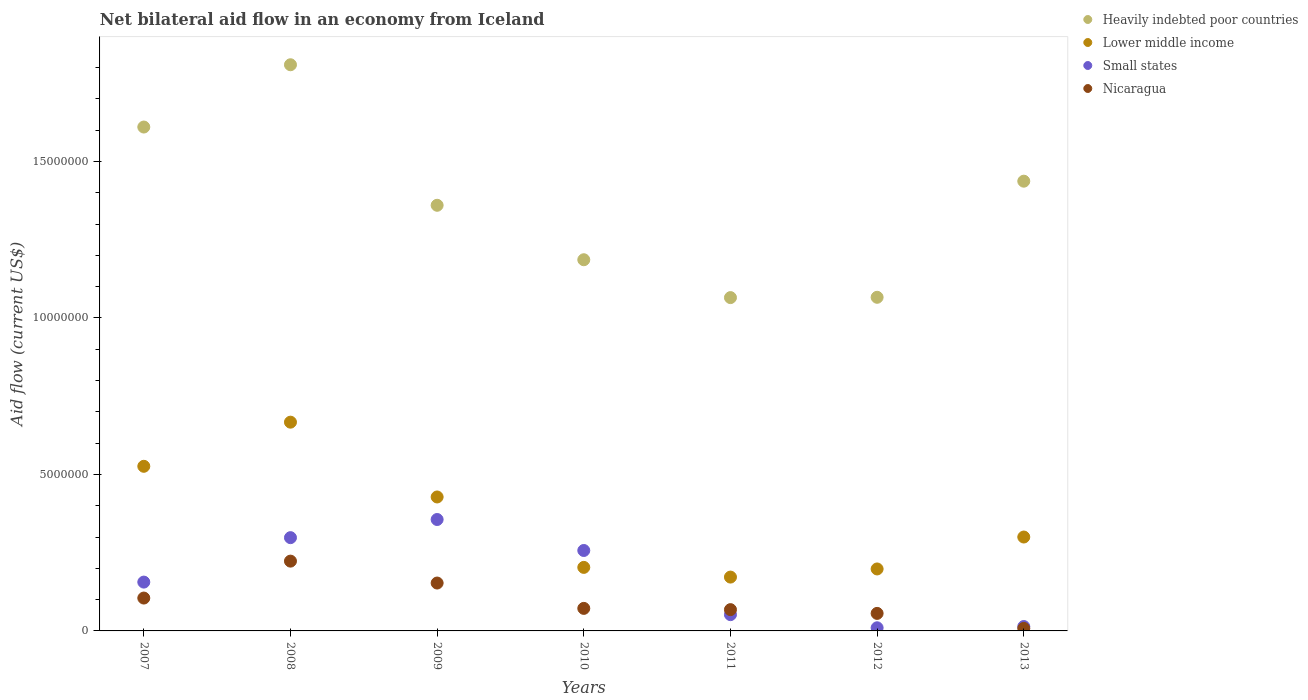What is the net bilateral aid flow in Nicaragua in 2010?
Provide a succinct answer. 7.20e+05. Across all years, what is the maximum net bilateral aid flow in Lower middle income?
Keep it short and to the point. 6.67e+06. Across all years, what is the minimum net bilateral aid flow in Lower middle income?
Your answer should be very brief. 1.72e+06. In which year was the net bilateral aid flow in Small states minimum?
Provide a short and direct response. 2012. What is the total net bilateral aid flow in Lower middle income in the graph?
Your answer should be compact. 2.49e+07. What is the difference between the net bilateral aid flow in Small states in 2007 and that in 2013?
Keep it short and to the point. 1.42e+06. What is the difference between the net bilateral aid flow in Lower middle income in 2009 and the net bilateral aid flow in Heavily indebted poor countries in 2008?
Your answer should be compact. -1.38e+07. What is the average net bilateral aid flow in Heavily indebted poor countries per year?
Provide a succinct answer. 1.36e+07. In the year 2011, what is the difference between the net bilateral aid flow in Lower middle income and net bilateral aid flow in Heavily indebted poor countries?
Your response must be concise. -8.93e+06. What is the ratio of the net bilateral aid flow in Heavily indebted poor countries in 2007 to that in 2009?
Your answer should be compact. 1.18. What is the difference between the highest and the second highest net bilateral aid flow in Heavily indebted poor countries?
Your answer should be compact. 1.99e+06. What is the difference between the highest and the lowest net bilateral aid flow in Small states?
Provide a succinct answer. 3.46e+06. In how many years, is the net bilateral aid flow in Small states greater than the average net bilateral aid flow in Small states taken over all years?
Make the answer very short. 3. How many dotlines are there?
Keep it short and to the point. 4. What is the difference between two consecutive major ticks on the Y-axis?
Make the answer very short. 5.00e+06. Are the values on the major ticks of Y-axis written in scientific E-notation?
Provide a short and direct response. No. Does the graph contain any zero values?
Provide a short and direct response. No. Does the graph contain grids?
Make the answer very short. No. Where does the legend appear in the graph?
Keep it short and to the point. Top right. How many legend labels are there?
Offer a terse response. 4. What is the title of the graph?
Make the answer very short. Net bilateral aid flow in an economy from Iceland. Does "Croatia" appear as one of the legend labels in the graph?
Provide a succinct answer. No. What is the label or title of the Y-axis?
Give a very brief answer. Aid flow (current US$). What is the Aid flow (current US$) in Heavily indebted poor countries in 2007?
Offer a very short reply. 1.61e+07. What is the Aid flow (current US$) in Lower middle income in 2007?
Your response must be concise. 5.26e+06. What is the Aid flow (current US$) of Small states in 2007?
Offer a terse response. 1.56e+06. What is the Aid flow (current US$) of Nicaragua in 2007?
Your response must be concise. 1.05e+06. What is the Aid flow (current US$) of Heavily indebted poor countries in 2008?
Provide a short and direct response. 1.81e+07. What is the Aid flow (current US$) of Lower middle income in 2008?
Your answer should be very brief. 6.67e+06. What is the Aid flow (current US$) of Small states in 2008?
Your answer should be very brief. 2.98e+06. What is the Aid flow (current US$) of Nicaragua in 2008?
Offer a very short reply. 2.23e+06. What is the Aid flow (current US$) in Heavily indebted poor countries in 2009?
Your response must be concise. 1.36e+07. What is the Aid flow (current US$) of Lower middle income in 2009?
Provide a succinct answer. 4.28e+06. What is the Aid flow (current US$) in Small states in 2009?
Your answer should be very brief. 3.56e+06. What is the Aid flow (current US$) of Nicaragua in 2009?
Make the answer very short. 1.53e+06. What is the Aid flow (current US$) of Heavily indebted poor countries in 2010?
Make the answer very short. 1.19e+07. What is the Aid flow (current US$) in Lower middle income in 2010?
Ensure brevity in your answer.  2.03e+06. What is the Aid flow (current US$) of Small states in 2010?
Offer a very short reply. 2.57e+06. What is the Aid flow (current US$) of Nicaragua in 2010?
Provide a short and direct response. 7.20e+05. What is the Aid flow (current US$) in Heavily indebted poor countries in 2011?
Offer a terse response. 1.06e+07. What is the Aid flow (current US$) of Lower middle income in 2011?
Keep it short and to the point. 1.72e+06. What is the Aid flow (current US$) in Small states in 2011?
Keep it short and to the point. 5.20e+05. What is the Aid flow (current US$) of Nicaragua in 2011?
Offer a very short reply. 6.80e+05. What is the Aid flow (current US$) in Heavily indebted poor countries in 2012?
Offer a very short reply. 1.07e+07. What is the Aid flow (current US$) of Lower middle income in 2012?
Offer a terse response. 1.98e+06. What is the Aid flow (current US$) of Small states in 2012?
Ensure brevity in your answer.  1.00e+05. What is the Aid flow (current US$) of Nicaragua in 2012?
Your response must be concise. 5.60e+05. What is the Aid flow (current US$) in Heavily indebted poor countries in 2013?
Give a very brief answer. 1.44e+07. What is the Aid flow (current US$) in Lower middle income in 2013?
Offer a terse response. 3.00e+06. Across all years, what is the maximum Aid flow (current US$) in Heavily indebted poor countries?
Offer a terse response. 1.81e+07. Across all years, what is the maximum Aid flow (current US$) in Lower middle income?
Offer a very short reply. 6.67e+06. Across all years, what is the maximum Aid flow (current US$) in Small states?
Your response must be concise. 3.56e+06. Across all years, what is the maximum Aid flow (current US$) in Nicaragua?
Your answer should be compact. 2.23e+06. Across all years, what is the minimum Aid flow (current US$) in Heavily indebted poor countries?
Offer a terse response. 1.06e+07. Across all years, what is the minimum Aid flow (current US$) of Lower middle income?
Provide a succinct answer. 1.72e+06. What is the total Aid flow (current US$) in Heavily indebted poor countries in the graph?
Make the answer very short. 9.53e+07. What is the total Aid flow (current US$) in Lower middle income in the graph?
Your answer should be compact. 2.49e+07. What is the total Aid flow (current US$) of Small states in the graph?
Ensure brevity in your answer.  1.14e+07. What is the total Aid flow (current US$) of Nicaragua in the graph?
Offer a terse response. 6.85e+06. What is the difference between the Aid flow (current US$) of Heavily indebted poor countries in 2007 and that in 2008?
Your answer should be compact. -1.99e+06. What is the difference between the Aid flow (current US$) in Lower middle income in 2007 and that in 2008?
Keep it short and to the point. -1.41e+06. What is the difference between the Aid flow (current US$) in Small states in 2007 and that in 2008?
Make the answer very short. -1.42e+06. What is the difference between the Aid flow (current US$) of Nicaragua in 2007 and that in 2008?
Provide a short and direct response. -1.18e+06. What is the difference between the Aid flow (current US$) in Heavily indebted poor countries in 2007 and that in 2009?
Your response must be concise. 2.50e+06. What is the difference between the Aid flow (current US$) in Lower middle income in 2007 and that in 2009?
Your answer should be compact. 9.80e+05. What is the difference between the Aid flow (current US$) in Small states in 2007 and that in 2009?
Provide a short and direct response. -2.00e+06. What is the difference between the Aid flow (current US$) in Nicaragua in 2007 and that in 2009?
Ensure brevity in your answer.  -4.80e+05. What is the difference between the Aid flow (current US$) in Heavily indebted poor countries in 2007 and that in 2010?
Your answer should be very brief. 4.24e+06. What is the difference between the Aid flow (current US$) in Lower middle income in 2007 and that in 2010?
Your answer should be compact. 3.23e+06. What is the difference between the Aid flow (current US$) in Small states in 2007 and that in 2010?
Make the answer very short. -1.01e+06. What is the difference between the Aid flow (current US$) of Nicaragua in 2007 and that in 2010?
Provide a short and direct response. 3.30e+05. What is the difference between the Aid flow (current US$) of Heavily indebted poor countries in 2007 and that in 2011?
Offer a very short reply. 5.45e+06. What is the difference between the Aid flow (current US$) in Lower middle income in 2007 and that in 2011?
Offer a very short reply. 3.54e+06. What is the difference between the Aid flow (current US$) of Small states in 2007 and that in 2011?
Your response must be concise. 1.04e+06. What is the difference between the Aid flow (current US$) of Heavily indebted poor countries in 2007 and that in 2012?
Ensure brevity in your answer.  5.44e+06. What is the difference between the Aid flow (current US$) of Lower middle income in 2007 and that in 2012?
Give a very brief answer. 3.28e+06. What is the difference between the Aid flow (current US$) in Small states in 2007 and that in 2012?
Offer a terse response. 1.46e+06. What is the difference between the Aid flow (current US$) of Heavily indebted poor countries in 2007 and that in 2013?
Offer a terse response. 1.73e+06. What is the difference between the Aid flow (current US$) of Lower middle income in 2007 and that in 2013?
Provide a short and direct response. 2.26e+06. What is the difference between the Aid flow (current US$) in Small states in 2007 and that in 2013?
Your answer should be compact. 1.42e+06. What is the difference between the Aid flow (current US$) in Nicaragua in 2007 and that in 2013?
Provide a succinct answer. 9.70e+05. What is the difference between the Aid flow (current US$) in Heavily indebted poor countries in 2008 and that in 2009?
Make the answer very short. 4.49e+06. What is the difference between the Aid flow (current US$) of Lower middle income in 2008 and that in 2009?
Ensure brevity in your answer.  2.39e+06. What is the difference between the Aid flow (current US$) of Small states in 2008 and that in 2009?
Keep it short and to the point. -5.80e+05. What is the difference between the Aid flow (current US$) of Nicaragua in 2008 and that in 2009?
Keep it short and to the point. 7.00e+05. What is the difference between the Aid flow (current US$) in Heavily indebted poor countries in 2008 and that in 2010?
Keep it short and to the point. 6.23e+06. What is the difference between the Aid flow (current US$) in Lower middle income in 2008 and that in 2010?
Make the answer very short. 4.64e+06. What is the difference between the Aid flow (current US$) in Small states in 2008 and that in 2010?
Give a very brief answer. 4.10e+05. What is the difference between the Aid flow (current US$) in Nicaragua in 2008 and that in 2010?
Your answer should be very brief. 1.51e+06. What is the difference between the Aid flow (current US$) of Heavily indebted poor countries in 2008 and that in 2011?
Make the answer very short. 7.44e+06. What is the difference between the Aid flow (current US$) of Lower middle income in 2008 and that in 2011?
Your answer should be compact. 4.95e+06. What is the difference between the Aid flow (current US$) of Small states in 2008 and that in 2011?
Offer a terse response. 2.46e+06. What is the difference between the Aid flow (current US$) of Nicaragua in 2008 and that in 2011?
Offer a terse response. 1.55e+06. What is the difference between the Aid flow (current US$) in Heavily indebted poor countries in 2008 and that in 2012?
Your response must be concise. 7.43e+06. What is the difference between the Aid flow (current US$) of Lower middle income in 2008 and that in 2012?
Offer a very short reply. 4.69e+06. What is the difference between the Aid flow (current US$) of Small states in 2008 and that in 2012?
Your answer should be very brief. 2.88e+06. What is the difference between the Aid flow (current US$) in Nicaragua in 2008 and that in 2012?
Ensure brevity in your answer.  1.67e+06. What is the difference between the Aid flow (current US$) in Heavily indebted poor countries in 2008 and that in 2013?
Make the answer very short. 3.72e+06. What is the difference between the Aid flow (current US$) of Lower middle income in 2008 and that in 2013?
Your answer should be very brief. 3.67e+06. What is the difference between the Aid flow (current US$) in Small states in 2008 and that in 2013?
Your answer should be compact. 2.84e+06. What is the difference between the Aid flow (current US$) in Nicaragua in 2008 and that in 2013?
Keep it short and to the point. 2.15e+06. What is the difference between the Aid flow (current US$) in Heavily indebted poor countries in 2009 and that in 2010?
Keep it short and to the point. 1.74e+06. What is the difference between the Aid flow (current US$) of Lower middle income in 2009 and that in 2010?
Provide a short and direct response. 2.25e+06. What is the difference between the Aid flow (current US$) in Small states in 2009 and that in 2010?
Offer a very short reply. 9.90e+05. What is the difference between the Aid flow (current US$) of Nicaragua in 2009 and that in 2010?
Make the answer very short. 8.10e+05. What is the difference between the Aid flow (current US$) in Heavily indebted poor countries in 2009 and that in 2011?
Give a very brief answer. 2.95e+06. What is the difference between the Aid flow (current US$) of Lower middle income in 2009 and that in 2011?
Offer a terse response. 2.56e+06. What is the difference between the Aid flow (current US$) of Small states in 2009 and that in 2011?
Your response must be concise. 3.04e+06. What is the difference between the Aid flow (current US$) of Nicaragua in 2009 and that in 2011?
Provide a short and direct response. 8.50e+05. What is the difference between the Aid flow (current US$) of Heavily indebted poor countries in 2009 and that in 2012?
Make the answer very short. 2.94e+06. What is the difference between the Aid flow (current US$) in Lower middle income in 2009 and that in 2012?
Your answer should be very brief. 2.30e+06. What is the difference between the Aid flow (current US$) in Small states in 2009 and that in 2012?
Keep it short and to the point. 3.46e+06. What is the difference between the Aid flow (current US$) of Nicaragua in 2009 and that in 2012?
Your response must be concise. 9.70e+05. What is the difference between the Aid flow (current US$) of Heavily indebted poor countries in 2009 and that in 2013?
Give a very brief answer. -7.70e+05. What is the difference between the Aid flow (current US$) in Lower middle income in 2009 and that in 2013?
Offer a terse response. 1.28e+06. What is the difference between the Aid flow (current US$) in Small states in 2009 and that in 2013?
Offer a very short reply. 3.42e+06. What is the difference between the Aid flow (current US$) of Nicaragua in 2009 and that in 2013?
Provide a short and direct response. 1.45e+06. What is the difference between the Aid flow (current US$) in Heavily indebted poor countries in 2010 and that in 2011?
Your answer should be very brief. 1.21e+06. What is the difference between the Aid flow (current US$) of Lower middle income in 2010 and that in 2011?
Provide a short and direct response. 3.10e+05. What is the difference between the Aid flow (current US$) in Small states in 2010 and that in 2011?
Your answer should be compact. 2.05e+06. What is the difference between the Aid flow (current US$) in Nicaragua in 2010 and that in 2011?
Provide a succinct answer. 4.00e+04. What is the difference between the Aid flow (current US$) in Heavily indebted poor countries in 2010 and that in 2012?
Your response must be concise. 1.20e+06. What is the difference between the Aid flow (current US$) in Lower middle income in 2010 and that in 2012?
Keep it short and to the point. 5.00e+04. What is the difference between the Aid flow (current US$) in Small states in 2010 and that in 2012?
Keep it short and to the point. 2.47e+06. What is the difference between the Aid flow (current US$) in Nicaragua in 2010 and that in 2012?
Your response must be concise. 1.60e+05. What is the difference between the Aid flow (current US$) of Heavily indebted poor countries in 2010 and that in 2013?
Offer a very short reply. -2.51e+06. What is the difference between the Aid flow (current US$) of Lower middle income in 2010 and that in 2013?
Your response must be concise. -9.70e+05. What is the difference between the Aid flow (current US$) in Small states in 2010 and that in 2013?
Provide a short and direct response. 2.43e+06. What is the difference between the Aid flow (current US$) in Nicaragua in 2010 and that in 2013?
Offer a very short reply. 6.40e+05. What is the difference between the Aid flow (current US$) in Small states in 2011 and that in 2012?
Provide a short and direct response. 4.20e+05. What is the difference between the Aid flow (current US$) of Nicaragua in 2011 and that in 2012?
Your response must be concise. 1.20e+05. What is the difference between the Aid flow (current US$) in Heavily indebted poor countries in 2011 and that in 2013?
Offer a terse response. -3.72e+06. What is the difference between the Aid flow (current US$) in Lower middle income in 2011 and that in 2013?
Your response must be concise. -1.28e+06. What is the difference between the Aid flow (current US$) in Small states in 2011 and that in 2013?
Your answer should be compact. 3.80e+05. What is the difference between the Aid flow (current US$) in Nicaragua in 2011 and that in 2013?
Your answer should be very brief. 6.00e+05. What is the difference between the Aid flow (current US$) in Heavily indebted poor countries in 2012 and that in 2013?
Offer a terse response. -3.71e+06. What is the difference between the Aid flow (current US$) of Lower middle income in 2012 and that in 2013?
Make the answer very short. -1.02e+06. What is the difference between the Aid flow (current US$) in Nicaragua in 2012 and that in 2013?
Make the answer very short. 4.80e+05. What is the difference between the Aid flow (current US$) of Heavily indebted poor countries in 2007 and the Aid flow (current US$) of Lower middle income in 2008?
Provide a short and direct response. 9.43e+06. What is the difference between the Aid flow (current US$) in Heavily indebted poor countries in 2007 and the Aid flow (current US$) in Small states in 2008?
Ensure brevity in your answer.  1.31e+07. What is the difference between the Aid flow (current US$) of Heavily indebted poor countries in 2007 and the Aid flow (current US$) of Nicaragua in 2008?
Your answer should be compact. 1.39e+07. What is the difference between the Aid flow (current US$) of Lower middle income in 2007 and the Aid flow (current US$) of Small states in 2008?
Keep it short and to the point. 2.28e+06. What is the difference between the Aid flow (current US$) in Lower middle income in 2007 and the Aid flow (current US$) in Nicaragua in 2008?
Provide a succinct answer. 3.03e+06. What is the difference between the Aid flow (current US$) in Small states in 2007 and the Aid flow (current US$) in Nicaragua in 2008?
Ensure brevity in your answer.  -6.70e+05. What is the difference between the Aid flow (current US$) in Heavily indebted poor countries in 2007 and the Aid flow (current US$) in Lower middle income in 2009?
Ensure brevity in your answer.  1.18e+07. What is the difference between the Aid flow (current US$) in Heavily indebted poor countries in 2007 and the Aid flow (current US$) in Small states in 2009?
Ensure brevity in your answer.  1.25e+07. What is the difference between the Aid flow (current US$) in Heavily indebted poor countries in 2007 and the Aid flow (current US$) in Nicaragua in 2009?
Provide a succinct answer. 1.46e+07. What is the difference between the Aid flow (current US$) of Lower middle income in 2007 and the Aid flow (current US$) of Small states in 2009?
Offer a very short reply. 1.70e+06. What is the difference between the Aid flow (current US$) in Lower middle income in 2007 and the Aid flow (current US$) in Nicaragua in 2009?
Offer a terse response. 3.73e+06. What is the difference between the Aid flow (current US$) in Heavily indebted poor countries in 2007 and the Aid flow (current US$) in Lower middle income in 2010?
Your answer should be compact. 1.41e+07. What is the difference between the Aid flow (current US$) in Heavily indebted poor countries in 2007 and the Aid flow (current US$) in Small states in 2010?
Make the answer very short. 1.35e+07. What is the difference between the Aid flow (current US$) in Heavily indebted poor countries in 2007 and the Aid flow (current US$) in Nicaragua in 2010?
Offer a terse response. 1.54e+07. What is the difference between the Aid flow (current US$) in Lower middle income in 2007 and the Aid flow (current US$) in Small states in 2010?
Your response must be concise. 2.69e+06. What is the difference between the Aid flow (current US$) of Lower middle income in 2007 and the Aid flow (current US$) of Nicaragua in 2010?
Offer a very short reply. 4.54e+06. What is the difference between the Aid flow (current US$) of Small states in 2007 and the Aid flow (current US$) of Nicaragua in 2010?
Give a very brief answer. 8.40e+05. What is the difference between the Aid flow (current US$) in Heavily indebted poor countries in 2007 and the Aid flow (current US$) in Lower middle income in 2011?
Your answer should be compact. 1.44e+07. What is the difference between the Aid flow (current US$) in Heavily indebted poor countries in 2007 and the Aid flow (current US$) in Small states in 2011?
Provide a short and direct response. 1.56e+07. What is the difference between the Aid flow (current US$) of Heavily indebted poor countries in 2007 and the Aid flow (current US$) of Nicaragua in 2011?
Your answer should be compact. 1.54e+07. What is the difference between the Aid flow (current US$) in Lower middle income in 2007 and the Aid flow (current US$) in Small states in 2011?
Your answer should be very brief. 4.74e+06. What is the difference between the Aid flow (current US$) of Lower middle income in 2007 and the Aid flow (current US$) of Nicaragua in 2011?
Ensure brevity in your answer.  4.58e+06. What is the difference between the Aid flow (current US$) in Small states in 2007 and the Aid flow (current US$) in Nicaragua in 2011?
Give a very brief answer. 8.80e+05. What is the difference between the Aid flow (current US$) of Heavily indebted poor countries in 2007 and the Aid flow (current US$) of Lower middle income in 2012?
Give a very brief answer. 1.41e+07. What is the difference between the Aid flow (current US$) in Heavily indebted poor countries in 2007 and the Aid flow (current US$) in Small states in 2012?
Ensure brevity in your answer.  1.60e+07. What is the difference between the Aid flow (current US$) of Heavily indebted poor countries in 2007 and the Aid flow (current US$) of Nicaragua in 2012?
Ensure brevity in your answer.  1.55e+07. What is the difference between the Aid flow (current US$) in Lower middle income in 2007 and the Aid flow (current US$) in Small states in 2012?
Offer a very short reply. 5.16e+06. What is the difference between the Aid flow (current US$) of Lower middle income in 2007 and the Aid flow (current US$) of Nicaragua in 2012?
Your response must be concise. 4.70e+06. What is the difference between the Aid flow (current US$) in Heavily indebted poor countries in 2007 and the Aid flow (current US$) in Lower middle income in 2013?
Give a very brief answer. 1.31e+07. What is the difference between the Aid flow (current US$) in Heavily indebted poor countries in 2007 and the Aid flow (current US$) in Small states in 2013?
Your response must be concise. 1.60e+07. What is the difference between the Aid flow (current US$) in Heavily indebted poor countries in 2007 and the Aid flow (current US$) in Nicaragua in 2013?
Your response must be concise. 1.60e+07. What is the difference between the Aid flow (current US$) in Lower middle income in 2007 and the Aid flow (current US$) in Small states in 2013?
Your response must be concise. 5.12e+06. What is the difference between the Aid flow (current US$) in Lower middle income in 2007 and the Aid flow (current US$) in Nicaragua in 2013?
Give a very brief answer. 5.18e+06. What is the difference between the Aid flow (current US$) of Small states in 2007 and the Aid flow (current US$) of Nicaragua in 2013?
Provide a short and direct response. 1.48e+06. What is the difference between the Aid flow (current US$) in Heavily indebted poor countries in 2008 and the Aid flow (current US$) in Lower middle income in 2009?
Ensure brevity in your answer.  1.38e+07. What is the difference between the Aid flow (current US$) in Heavily indebted poor countries in 2008 and the Aid flow (current US$) in Small states in 2009?
Ensure brevity in your answer.  1.45e+07. What is the difference between the Aid flow (current US$) in Heavily indebted poor countries in 2008 and the Aid flow (current US$) in Nicaragua in 2009?
Give a very brief answer. 1.66e+07. What is the difference between the Aid flow (current US$) in Lower middle income in 2008 and the Aid flow (current US$) in Small states in 2009?
Give a very brief answer. 3.11e+06. What is the difference between the Aid flow (current US$) in Lower middle income in 2008 and the Aid flow (current US$) in Nicaragua in 2009?
Offer a very short reply. 5.14e+06. What is the difference between the Aid flow (current US$) of Small states in 2008 and the Aid flow (current US$) of Nicaragua in 2009?
Make the answer very short. 1.45e+06. What is the difference between the Aid flow (current US$) of Heavily indebted poor countries in 2008 and the Aid flow (current US$) of Lower middle income in 2010?
Ensure brevity in your answer.  1.61e+07. What is the difference between the Aid flow (current US$) of Heavily indebted poor countries in 2008 and the Aid flow (current US$) of Small states in 2010?
Provide a succinct answer. 1.55e+07. What is the difference between the Aid flow (current US$) in Heavily indebted poor countries in 2008 and the Aid flow (current US$) in Nicaragua in 2010?
Offer a terse response. 1.74e+07. What is the difference between the Aid flow (current US$) of Lower middle income in 2008 and the Aid flow (current US$) of Small states in 2010?
Make the answer very short. 4.10e+06. What is the difference between the Aid flow (current US$) of Lower middle income in 2008 and the Aid flow (current US$) of Nicaragua in 2010?
Provide a short and direct response. 5.95e+06. What is the difference between the Aid flow (current US$) in Small states in 2008 and the Aid flow (current US$) in Nicaragua in 2010?
Offer a very short reply. 2.26e+06. What is the difference between the Aid flow (current US$) in Heavily indebted poor countries in 2008 and the Aid flow (current US$) in Lower middle income in 2011?
Keep it short and to the point. 1.64e+07. What is the difference between the Aid flow (current US$) in Heavily indebted poor countries in 2008 and the Aid flow (current US$) in Small states in 2011?
Provide a short and direct response. 1.76e+07. What is the difference between the Aid flow (current US$) of Heavily indebted poor countries in 2008 and the Aid flow (current US$) of Nicaragua in 2011?
Ensure brevity in your answer.  1.74e+07. What is the difference between the Aid flow (current US$) of Lower middle income in 2008 and the Aid flow (current US$) of Small states in 2011?
Your answer should be compact. 6.15e+06. What is the difference between the Aid flow (current US$) in Lower middle income in 2008 and the Aid flow (current US$) in Nicaragua in 2011?
Offer a very short reply. 5.99e+06. What is the difference between the Aid flow (current US$) of Small states in 2008 and the Aid flow (current US$) of Nicaragua in 2011?
Your answer should be compact. 2.30e+06. What is the difference between the Aid flow (current US$) in Heavily indebted poor countries in 2008 and the Aid flow (current US$) in Lower middle income in 2012?
Make the answer very short. 1.61e+07. What is the difference between the Aid flow (current US$) in Heavily indebted poor countries in 2008 and the Aid flow (current US$) in Small states in 2012?
Keep it short and to the point. 1.80e+07. What is the difference between the Aid flow (current US$) of Heavily indebted poor countries in 2008 and the Aid flow (current US$) of Nicaragua in 2012?
Provide a succinct answer. 1.75e+07. What is the difference between the Aid flow (current US$) of Lower middle income in 2008 and the Aid flow (current US$) of Small states in 2012?
Provide a succinct answer. 6.57e+06. What is the difference between the Aid flow (current US$) in Lower middle income in 2008 and the Aid flow (current US$) in Nicaragua in 2012?
Provide a short and direct response. 6.11e+06. What is the difference between the Aid flow (current US$) of Small states in 2008 and the Aid flow (current US$) of Nicaragua in 2012?
Give a very brief answer. 2.42e+06. What is the difference between the Aid flow (current US$) in Heavily indebted poor countries in 2008 and the Aid flow (current US$) in Lower middle income in 2013?
Offer a terse response. 1.51e+07. What is the difference between the Aid flow (current US$) of Heavily indebted poor countries in 2008 and the Aid flow (current US$) of Small states in 2013?
Ensure brevity in your answer.  1.80e+07. What is the difference between the Aid flow (current US$) of Heavily indebted poor countries in 2008 and the Aid flow (current US$) of Nicaragua in 2013?
Offer a very short reply. 1.80e+07. What is the difference between the Aid flow (current US$) of Lower middle income in 2008 and the Aid flow (current US$) of Small states in 2013?
Your answer should be very brief. 6.53e+06. What is the difference between the Aid flow (current US$) of Lower middle income in 2008 and the Aid flow (current US$) of Nicaragua in 2013?
Offer a terse response. 6.59e+06. What is the difference between the Aid flow (current US$) in Small states in 2008 and the Aid flow (current US$) in Nicaragua in 2013?
Ensure brevity in your answer.  2.90e+06. What is the difference between the Aid flow (current US$) of Heavily indebted poor countries in 2009 and the Aid flow (current US$) of Lower middle income in 2010?
Keep it short and to the point. 1.16e+07. What is the difference between the Aid flow (current US$) of Heavily indebted poor countries in 2009 and the Aid flow (current US$) of Small states in 2010?
Offer a very short reply. 1.10e+07. What is the difference between the Aid flow (current US$) of Heavily indebted poor countries in 2009 and the Aid flow (current US$) of Nicaragua in 2010?
Offer a very short reply. 1.29e+07. What is the difference between the Aid flow (current US$) in Lower middle income in 2009 and the Aid flow (current US$) in Small states in 2010?
Ensure brevity in your answer.  1.71e+06. What is the difference between the Aid flow (current US$) in Lower middle income in 2009 and the Aid flow (current US$) in Nicaragua in 2010?
Provide a short and direct response. 3.56e+06. What is the difference between the Aid flow (current US$) of Small states in 2009 and the Aid flow (current US$) of Nicaragua in 2010?
Your answer should be compact. 2.84e+06. What is the difference between the Aid flow (current US$) of Heavily indebted poor countries in 2009 and the Aid flow (current US$) of Lower middle income in 2011?
Make the answer very short. 1.19e+07. What is the difference between the Aid flow (current US$) in Heavily indebted poor countries in 2009 and the Aid flow (current US$) in Small states in 2011?
Give a very brief answer. 1.31e+07. What is the difference between the Aid flow (current US$) of Heavily indebted poor countries in 2009 and the Aid flow (current US$) of Nicaragua in 2011?
Provide a short and direct response. 1.29e+07. What is the difference between the Aid flow (current US$) of Lower middle income in 2009 and the Aid flow (current US$) of Small states in 2011?
Your answer should be very brief. 3.76e+06. What is the difference between the Aid flow (current US$) in Lower middle income in 2009 and the Aid flow (current US$) in Nicaragua in 2011?
Your answer should be very brief. 3.60e+06. What is the difference between the Aid flow (current US$) of Small states in 2009 and the Aid flow (current US$) of Nicaragua in 2011?
Your answer should be very brief. 2.88e+06. What is the difference between the Aid flow (current US$) of Heavily indebted poor countries in 2009 and the Aid flow (current US$) of Lower middle income in 2012?
Ensure brevity in your answer.  1.16e+07. What is the difference between the Aid flow (current US$) of Heavily indebted poor countries in 2009 and the Aid flow (current US$) of Small states in 2012?
Give a very brief answer. 1.35e+07. What is the difference between the Aid flow (current US$) of Heavily indebted poor countries in 2009 and the Aid flow (current US$) of Nicaragua in 2012?
Your answer should be very brief. 1.30e+07. What is the difference between the Aid flow (current US$) in Lower middle income in 2009 and the Aid flow (current US$) in Small states in 2012?
Your response must be concise. 4.18e+06. What is the difference between the Aid flow (current US$) in Lower middle income in 2009 and the Aid flow (current US$) in Nicaragua in 2012?
Your response must be concise. 3.72e+06. What is the difference between the Aid flow (current US$) of Heavily indebted poor countries in 2009 and the Aid flow (current US$) of Lower middle income in 2013?
Ensure brevity in your answer.  1.06e+07. What is the difference between the Aid flow (current US$) in Heavily indebted poor countries in 2009 and the Aid flow (current US$) in Small states in 2013?
Provide a short and direct response. 1.35e+07. What is the difference between the Aid flow (current US$) of Heavily indebted poor countries in 2009 and the Aid flow (current US$) of Nicaragua in 2013?
Offer a very short reply. 1.35e+07. What is the difference between the Aid flow (current US$) of Lower middle income in 2009 and the Aid flow (current US$) of Small states in 2013?
Give a very brief answer. 4.14e+06. What is the difference between the Aid flow (current US$) of Lower middle income in 2009 and the Aid flow (current US$) of Nicaragua in 2013?
Keep it short and to the point. 4.20e+06. What is the difference between the Aid flow (current US$) of Small states in 2009 and the Aid flow (current US$) of Nicaragua in 2013?
Offer a very short reply. 3.48e+06. What is the difference between the Aid flow (current US$) of Heavily indebted poor countries in 2010 and the Aid flow (current US$) of Lower middle income in 2011?
Your response must be concise. 1.01e+07. What is the difference between the Aid flow (current US$) in Heavily indebted poor countries in 2010 and the Aid flow (current US$) in Small states in 2011?
Offer a very short reply. 1.13e+07. What is the difference between the Aid flow (current US$) in Heavily indebted poor countries in 2010 and the Aid flow (current US$) in Nicaragua in 2011?
Provide a succinct answer. 1.12e+07. What is the difference between the Aid flow (current US$) in Lower middle income in 2010 and the Aid flow (current US$) in Small states in 2011?
Offer a terse response. 1.51e+06. What is the difference between the Aid flow (current US$) in Lower middle income in 2010 and the Aid flow (current US$) in Nicaragua in 2011?
Your response must be concise. 1.35e+06. What is the difference between the Aid flow (current US$) of Small states in 2010 and the Aid flow (current US$) of Nicaragua in 2011?
Make the answer very short. 1.89e+06. What is the difference between the Aid flow (current US$) of Heavily indebted poor countries in 2010 and the Aid flow (current US$) of Lower middle income in 2012?
Make the answer very short. 9.88e+06. What is the difference between the Aid flow (current US$) of Heavily indebted poor countries in 2010 and the Aid flow (current US$) of Small states in 2012?
Provide a short and direct response. 1.18e+07. What is the difference between the Aid flow (current US$) in Heavily indebted poor countries in 2010 and the Aid flow (current US$) in Nicaragua in 2012?
Make the answer very short. 1.13e+07. What is the difference between the Aid flow (current US$) of Lower middle income in 2010 and the Aid flow (current US$) of Small states in 2012?
Offer a very short reply. 1.93e+06. What is the difference between the Aid flow (current US$) in Lower middle income in 2010 and the Aid flow (current US$) in Nicaragua in 2012?
Provide a succinct answer. 1.47e+06. What is the difference between the Aid flow (current US$) of Small states in 2010 and the Aid flow (current US$) of Nicaragua in 2012?
Give a very brief answer. 2.01e+06. What is the difference between the Aid flow (current US$) in Heavily indebted poor countries in 2010 and the Aid flow (current US$) in Lower middle income in 2013?
Offer a very short reply. 8.86e+06. What is the difference between the Aid flow (current US$) of Heavily indebted poor countries in 2010 and the Aid flow (current US$) of Small states in 2013?
Provide a short and direct response. 1.17e+07. What is the difference between the Aid flow (current US$) in Heavily indebted poor countries in 2010 and the Aid flow (current US$) in Nicaragua in 2013?
Provide a short and direct response. 1.18e+07. What is the difference between the Aid flow (current US$) in Lower middle income in 2010 and the Aid flow (current US$) in Small states in 2013?
Keep it short and to the point. 1.89e+06. What is the difference between the Aid flow (current US$) in Lower middle income in 2010 and the Aid flow (current US$) in Nicaragua in 2013?
Your answer should be very brief. 1.95e+06. What is the difference between the Aid flow (current US$) of Small states in 2010 and the Aid flow (current US$) of Nicaragua in 2013?
Offer a very short reply. 2.49e+06. What is the difference between the Aid flow (current US$) of Heavily indebted poor countries in 2011 and the Aid flow (current US$) of Lower middle income in 2012?
Offer a very short reply. 8.67e+06. What is the difference between the Aid flow (current US$) in Heavily indebted poor countries in 2011 and the Aid flow (current US$) in Small states in 2012?
Make the answer very short. 1.06e+07. What is the difference between the Aid flow (current US$) in Heavily indebted poor countries in 2011 and the Aid flow (current US$) in Nicaragua in 2012?
Your response must be concise. 1.01e+07. What is the difference between the Aid flow (current US$) of Lower middle income in 2011 and the Aid flow (current US$) of Small states in 2012?
Your answer should be compact. 1.62e+06. What is the difference between the Aid flow (current US$) of Lower middle income in 2011 and the Aid flow (current US$) of Nicaragua in 2012?
Your response must be concise. 1.16e+06. What is the difference between the Aid flow (current US$) of Small states in 2011 and the Aid flow (current US$) of Nicaragua in 2012?
Make the answer very short. -4.00e+04. What is the difference between the Aid flow (current US$) of Heavily indebted poor countries in 2011 and the Aid flow (current US$) of Lower middle income in 2013?
Keep it short and to the point. 7.65e+06. What is the difference between the Aid flow (current US$) in Heavily indebted poor countries in 2011 and the Aid flow (current US$) in Small states in 2013?
Your response must be concise. 1.05e+07. What is the difference between the Aid flow (current US$) of Heavily indebted poor countries in 2011 and the Aid flow (current US$) of Nicaragua in 2013?
Make the answer very short. 1.06e+07. What is the difference between the Aid flow (current US$) in Lower middle income in 2011 and the Aid flow (current US$) in Small states in 2013?
Make the answer very short. 1.58e+06. What is the difference between the Aid flow (current US$) of Lower middle income in 2011 and the Aid flow (current US$) of Nicaragua in 2013?
Keep it short and to the point. 1.64e+06. What is the difference between the Aid flow (current US$) of Small states in 2011 and the Aid flow (current US$) of Nicaragua in 2013?
Offer a terse response. 4.40e+05. What is the difference between the Aid flow (current US$) of Heavily indebted poor countries in 2012 and the Aid flow (current US$) of Lower middle income in 2013?
Your response must be concise. 7.66e+06. What is the difference between the Aid flow (current US$) of Heavily indebted poor countries in 2012 and the Aid flow (current US$) of Small states in 2013?
Give a very brief answer. 1.05e+07. What is the difference between the Aid flow (current US$) of Heavily indebted poor countries in 2012 and the Aid flow (current US$) of Nicaragua in 2013?
Give a very brief answer. 1.06e+07. What is the difference between the Aid flow (current US$) in Lower middle income in 2012 and the Aid flow (current US$) in Small states in 2013?
Your answer should be very brief. 1.84e+06. What is the difference between the Aid flow (current US$) of Lower middle income in 2012 and the Aid flow (current US$) of Nicaragua in 2013?
Ensure brevity in your answer.  1.90e+06. What is the average Aid flow (current US$) of Heavily indebted poor countries per year?
Give a very brief answer. 1.36e+07. What is the average Aid flow (current US$) of Lower middle income per year?
Offer a terse response. 3.56e+06. What is the average Aid flow (current US$) in Small states per year?
Provide a succinct answer. 1.63e+06. What is the average Aid flow (current US$) of Nicaragua per year?
Your answer should be very brief. 9.79e+05. In the year 2007, what is the difference between the Aid flow (current US$) in Heavily indebted poor countries and Aid flow (current US$) in Lower middle income?
Your response must be concise. 1.08e+07. In the year 2007, what is the difference between the Aid flow (current US$) in Heavily indebted poor countries and Aid flow (current US$) in Small states?
Offer a very short reply. 1.45e+07. In the year 2007, what is the difference between the Aid flow (current US$) of Heavily indebted poor countries and Aid flow (current US$) of Nicaragua?
Offer a very short reply. 1.50e+07. In the year 2007, what is the difference between the Aid flow (current US$) of Lower middle income and Aid flow (current US$) of Small states?
Your response must be concise. 3.70e+06. In the year 2007, what is the difference between the Aid flow (current US$) in Lower middle income and Aid flow (current US$) in Nicaragua?
Ensure brevity in your answer.  4.21e+06. In the year 2007, what is the difference between the Aid flow (current US$) in Small states and Aid flow (current US$) in Nicaragua?
Your answer should be compact. 5.10e+05. In the year 2008, what is the difference between the Aid flow (current US$) of Heavily indebted poor countries and Aid flow (current US$) of Lower middle income?
Make the answer very short. 1.14e+07. In the year 2008, what is the difference between the Aid flow (current US$) in Heavily indebted poor countries and Aid flow (current US$) in Small states?
Your response must be concise. 1.51e+07. In the year 2008, what is the difference between the Aid flow (current US$) in Heavily indebted poor countries and Aid flow (current US$) in Nicaragua?
Your response must be concise. 1.59e+07. In the year 2008, what is the difference between the Aid flow (current US$) in Lower middle income and Aid flow (current US$) in Small states?
Give a very brief answer. 3.69e+06. In the year 2008, what is the difference between the Aid flow (current US$) of Lower middle income and Aid flow (current US$) of Nicaragua?
Make the answer very short. 4.44e+06. In the year 2008, what is the difference between the Aid flow (current US$) in Small states and Aid flow (current US$) in Nicaragua?
Provide a short and direct response. 7.50e+05. In the year 2009, what is the difference between the Aid flow (current US$) in Heavily indebted poor countries and Aid flow (current US$) in Lower middle income?
Your response must be concise. 9.32e+06. In the year 2009, what is the difference between the Aid flow (current US$) in Heavily indebted poor countries and Aid flow (current US$) in Small states?
Provide a succinct answer. 1.00e+07. In the year 2009, what is the difference between the Aid flow (current US$) of Heavily indebted poor countries and Aid flow (current US$) of Nicaragua?
Make the answer very short. 1.21e+07. In the year 2009, what is the difference between the Aid flow (current US$) in Lower middle income and Aid flow (current US$) in Small states?
Your response must be concise. 7.20e+05. In the year 2009, what is the difference between the Aid flow (current US$) in Lower middle income and Aid flow (current US$) in Nicaragua?
Provide a succinct answer. 2.75e+06. In the year 2009, what is the difference between the Aid flow (current US$) of Small states and Aid flow (current US$) of Nicaragua?
Offer a very short reply. 2.03e+06. In the year 2010, what is the difference between the Aid flow (current US$) of Heavily indebted poor countries and Aid flow (current US$) of Lower middle income?
Provide a short and direct response. 9.83e+06. In the year 2010, what is the difference between the Aid flow (current US$) in Heavily indebted poor countries and Aid flow (current US$) in Small states?
Provide a succinct answer. 9.29e+06. In the year 2010, what is the difference between the Aid flow (current US$) of Heavily indebted poor countries and Aid flow (current US$) of Nicaragua?
Offer a terse response. 1.11e+07. In the year 2010, what is the difference between the Aid flow (current US$) of Lower middle income and Aid flow (current US$) of Small states?
Offer a terse response. -5.40e+05. In the year 2010, what is the difference between the Aid flow (current US$) in Lower middle income and Aid flow (current US$) in Nicaragua?
Keep it short and to the point. 1.31e+06. In the year 2010, what is the difference between the Aid flow (current US$) in Small states and Aid flow (current US$) in Nicaragua?
Give a very brief answer. 1.85e+06. In the year 2011, what is the difference between the Aid flow (current US$) of Heavily indebted poor countries and Aid flow (current US$) of Lower middle income?
Your answer should be very brief. 8.93e+06. In the year 2011, what is the difference between the Aid flow (current US$) of Heavily indebted poor countries and Aid flow (current US$) of Small states?
Make the answer very short. 1.01e+07. In the year 2011, what is the difference between the Aid flow (current US$) of Heavily indebted poor countries and Aid flow (current US$) of Nicaragua?
Keep it short and to the point. 9.97e+06. In the year 2011, what is the difference between the Aid flow (current US$) of Lower middle income and Aid flow (current US$) of Small states?
Make the answer very short. 1.20e+06. In the year 2011, what is the difference between the Aid flow (current US$) of Lower middle income and Aid flow (current US$) of Nicaragua?
Offer a terse response. 1.04e+06. In the year 2012, what is the difference between the Aid flow (current US$) in Heavily indebted poor countries and Aid flow (current US$) in Lower middle income?
Offer a terse response. 8.68e+06. In the year 2012, what is the difference between the Aid flow (current US$) in Heavily indebted poor countries and Aid flow (current US$) in Small states?
Provide a short and direct response. 1.06e+07. In the year 2012, what is the difference between the Aid flow (current US$) of Heavily indebted poor countries and Aid flow (current US$) of Nicaragua?
Your response must be concise. 1.01e+07. In the year 2012, what is the difference between the Aid flow (current US$) of Lower middle income and Aid flow (current US$) of Small states?
Provide a succinct answer. 1.88e+06. In the year 2012, what is the difference between the Aid flow (current US$) of Lower middle income and Aid flow (current US$) of Nicaragua?
Ensure brevity in your answer.  1.42e+06. In the year 2012, what is the difference between the Aid flow (current US$) in Small states and Aid flow (current US$) in Nicaragua?
Provide a succinct answer. -4.60e+05. In the year 2013, what is the difference between the Aid flow (current US$) in Heavily indebted poor countries and Aid flow (current US$) in Lower middle income?
Offer a terse response. 1.14e+07. In the year 2013, what is the difference between the Aid flow (current US$) in Heavily indebted poor countries and Aid flow (current US$) in Small states?
Provide a succinct answer. 1.42e+07. In the year 2013, what is the difference between the Aid flow (current US$) in Heavily indebted poor countries and Aid flow (current US$) in Nicaragua?
Provide a succinct answer. 1.43e+07. In the year 2013, what is the difference between the Aid flow (current US$) of Lower middle income and Aid flow (current US$) of Small states?
Keep it short and to the point. 2.86e+06. In the year 2013, what is the difference between the Aid flow (current US$) in Lower middle income and Aid flow (current US$) in Nicaragua?
Give a very brief answer. 2.92e+06. What is the ratio of the Aid flow (current US$) of Heavily indebted poor countries in 2007 to that in 2008?
Ensure brevity in your answer.  0.89. What is the ratio of the Aid flow (current US$) of Lower middle income in 2007 to that in 2008?
Your response must be concise. 0.79. What is the ratio of the Aid flow (current US$) of Small states in 2007 to that in 2008?
Your response must be concise. 0.52. What is the ratio of the Aid flow (current US$) of Nicaragua in 2007 to that in 2008?
Provide a succinct answer. 0.47. What is the ratio of the Aid flow (current US$) in Heavily indebted poor countries in 2007 to that in 2009?
Your response must be concise. 1.18. What is the ratio of the Aid flow (current US$) in Lower middle income in 2007 to that in 2009?
Your answer should be very brief. 1.23. What is the ratio of the Aid flow (current US$) of Small states in 2007 to that in 2009?
Ensure brevity in your answer.  0.44. What is the ratio of the Aid flow (current US$) of Nicaragua in 2007 to that in 2009?
Provide a short and direct response. 0.69. What is the ratio of the Aid flow (current US$) of Heavily indebted poor countries in 2007 to that in 2010?
Offer a very short reply. 1.36. What is the ratio of the Aid flow (current US$) of Lower middle income in 2007 to that in 2010?
Your answer should be compact. 2.59. What is the ratio of the Aid flow (current US$) of Small states in 2007 to that in 2010?
Keep it short and to the point. 0.61. What is the ratio of the Aid flow (current US$) in Nicaragua in 2007 to that in 2010?
Ensure brevity in your answer.  1.46. What is the ratio of the Aid flow (current US$) of Heavily indebted poor countries in 2007 to that in 2011?
Keep it short and to the point. 1.51. What is the ratio of the Aid flow (current US$) in Lower middle income in 2007 to that in 2011?
Provide a succinct answer. 3.06. What is the ratio of the Aid flow (current US$) of Small states in 2007 to that in 2011?
Your answer should be very brief. 3. What is the ratio of the Aid flow (current US$) of Nicaragua in 2007 to that in 2011?
Ensure brevity in your answer.  1.54. What is the ratio of the Aid flow (current US$) in Heavily indebted poor countries in 2007 to that in 2012?
Provide a succinct answer. 1.51. What is the ratio of the Aid flow (current US$) in Lower middle income in 2007 to that in 2012?
Keep it short and to the point. 2.66. What is the ratio of the Aid flow (current US$) in Small states in 2007 to that in 2012?
Your answer should be very brief. 15.6. What is the ratio of the Aid flow (current US$) of Nicaragua in 2007 to that in 2012?
Your answer should be compact. 1.88. What is the ratio of the Aid flow (current US$) in Heavily indebted poor countries in 2007 to that in 2013?
Ensure brevity in your answer.  1.12. What is the ratio of the Aid flow (current US$) of Lower middle income in 2007 to that in 2013?
Keep it short and to the point. 1.75. What is the ratio of the Aid flow (current US$) in Small states in 2007 to that in 2013?
Your response must be concise. 11.14. What is the ratio of the Aid flow (current US$) of Nicaragua in 2007 to that in 2013?
Offer a terse response. 13.12. What is the ratio of the Aid flow (current US$) in Heavily indebted poor countries in 2008 to that in 2009?
Make the answer very short. 1.33. What is the ratio of the Aid flow (current US$) in Lower middle income in 2008 to that in 2009?
Offer a terse response. 1.56. What is the ratio of the Aid flow (current US$) of Small states in 2008 to that in 2009?
Offer a very short reply. 0.84. What is the ratio of the Aid flow (current US$) in Nicaragua in 2008 to that in 2009?
Your response must be concise. 1.46. What is the ratio of the Aid flow (current US$) of Heavily indebted poor countries in 2008 to that in 2010?
Offer a terse response. 1.53. What is the ratio of the Aid flow (current US$) in Lower middle income in 2008 to that in 2010?
Your answer should be very brief. 3.29. What is the ratio of the Aid flow (current US$) in Small states in 2008 to that in 2010?
Offer a terse response. 1.16. What is the ratio of the Aid flow (current US$) of Nicaragua in 2008 to that in 2010?
Offer a very short reply. 3.1. What is the ratio of the Aid flow (current US$) of Heavily indebted poor countries in 2008 to that in 2011?
Ensure brevity in your answer.  1.7. What is the ratio of the Aid flow (current US$) of Lower middle income in 2008 to that in 2011?
Your response must be concise. 3.88. What is the ratio of the Aid flow (current US$) of Small states in 2008 to that in 2011?
Give a very brief answer. 5.73. What is the ratio of the Aid flow (current US$) in Nicaragua in 2008 to that in 2011?
Give a very brief answer. 3.28. What is the ratio of the Aid flow (current US$) in Heavily indebted poor countries in 2008 to that in 2012?
Your answer should be very brief. 1.7. What is the ratio of the Aid flow (current US$) in Lower middle income in 2008 to that in 2012?
Your response must be concise. 3.37. What is the ratio of the Aid flow (current US$) of Small states in 2008 to that in 2012?
Give a very brief answer. 29.8. What is the ratio of the Aid flow (current US$) in Nicaragua in 2008 to that in 2012?
Your answer should be very brief. 3.98. What is the ratio of the Aid flow (current US$) of Heavily indebted poor countries in 2008 to that in 2013?
Offer a very short reply. 1.26. What is the ratio of the Aid flow (current US$) in Lower middle income in 2008 to that in 2013?
Your response must be concise. 2.22. What is the ratio of the Aid flow (current US$) of Small states in 2008 to that in 2013?
Offer a very short reply. 21.29. What is the ratio of the Aid flow (current US$) in Nicaragua in 2008 to that in 2013?
Provide a short and direct response. 27.88. What is the ratio of the Aid flow (current US$) of Heavily indebted poor countries in 2009 to that in 2010?
Give a very brief answer. 1.15. What is the ratio of the Aid flow (current US$) of Lower middle income in 2009 to that in 2010?
Your answer should be very brief. 2.11. What is the ratio of the Aid flow (current US$) of Small states in 2009 to that in 2010?
Make the answer very short. 1.39. What is the ratio of the Aid flow (current US$) in Nicaragua in 2009 to that in 2010?
Give a very brief answer. 2.12. What is the ratio of the Aid flow (current US$) in Heavily indebted poor countries in 2009 to that in 2011?
Keep it short and to the point. 1.28. What is the ratio of the Aid flow (current US$) of Lower middle income in 2009 to that in 2011?
Your answer should be very brief. 2.49. What is the ratio of the Aid flow (current US$) in Small states in 2009 to that in 2011?
Make the answer very short. 6.85. What is the ratio of the Aid flow (current US$) of Nicaragua in 2009 to that in 2011?
Ensure brevity in your answer.  2.25. What is the ratio of the Aid flow (current US$) in Heavily indebted poor countries in 2009 to that in 2012?
Your answer should be very brief. 1.28. What is the ratio of the Aid flow (current US$) in Lower middle income in 2009 to that in 2012?
Make the answer very short. 2.16. What is the ratio of the Aid flow (current US$) in Small states in 2009 to that in 2012?
Offer a terse response. 35.6. What is the ratio of the Aid flow (current US$) of Nicaragua in 2009 to that in 2012?
Your answer should be very brief. 2.73. What is the ratio of the Aid flow (current US$) in Heavily indebted poor countries in 2009 to that in 2013?
Make the answer very short. 0.95. What is the ratio of the Aid flow (current US$) of Lower middle income in 2009 to that in 2013?
Provide a succinct answer. 1.43. What is the ratio of the Aid flow (current US$) in Small states in 2009 to that in 2013?
Make the answer very short. 25.43. What is the ratio of the Aid flow (current US$) of Nicaragua in 2009 to that in 2013?
Keep it short and to the point. 19.12. What is the ratio of the Aid flow (current US$) in Heavily indebted poor countries in 2010 to that in 2011?
Provide a succinct answer. 1.11. What is the ratio of the Aid flow (current US$) of Lower middle income in 2010 to that in 2011?
Your answer should be very brief. 1.18. What is the ratio of the Aid flow (current US$) of Small states in 2010 to that in 2011?
Offer a very short reply. 4.94. What is the ratio of the Aid flow (current US$) of Nicaragua in 2010 to that in 2011?
Keep it short and to the point. 1.06. What is the ratio of the Aid flow (current US$) of Heavily indebted poor countries in 2010 to that in 2012?
Provide a short and direct response. 1.11. What is the ratio of the Aid flow (current US$) in Lower middle income in 2010 to that in 2012?
Give a very brief answer. 1.03. What is the ratio of the Aid flow (current US$) of Small states in 2010 to that in 2012?
Provide a short and direct response. 25.7. What is the ratio of the Aid flow (current US$) of Nicaragua in 2010 to that in 2012?
Your answer should be compact. 1.29. What is the ratio of the Aid flow (current US$) in Heavily indebted poor countries in 2010 to that in 2013?
Offer a very short reply. 0.83. What is the ratio of the Aid flow (current US$) in Lower middle income in 2010 to that in 2013?
Give a very brief answer. 0.68. What is the ratio of the Aid flow (current US$) of Small states in 2010 to that in 2013?
Offer a terse response. 18.36. What is the ratio of the Aid flow (current US$) in Nicaragua in 2010 to that in 2013?
Offer a terse response. 9. What is the ratio of the Aid flow (current US$) in Lower middle income in 2011 to that in 2012?
Your answer should be very brief. 0.87. What is the ratio of the Aid flow (current US$) in Small states in 2011 to that in 2012?
Keep it short and to the point. 5.2. What is the ratio of the Aid flow (current US$) in Nicaragua in 2011 to that in 2012?
Give a very brief answer. 1.21. What is the ratio of the Aid flow (current US$) of Heavily indebted poor countries in 2011 to that in 2013?
Your answer should be very brief. 0.74. What is the ratio of the Aid flow (current US$) of Lower middle income in 2011 to that in 2013?
Your response must be concise. 0.57. What is the ratio of the Aid flow (current US$) in Small states in 2011 to that in 2013?
Give a very brief answer. 3.71. What is the ratio of the Aid flow (current US$) in Heavily indebted poor countries in 2012 to that in 2013?
Your answer should be very brief. 0.74. What is the ratio of the Aid flow (current US$) in Lower middle income in 2012 to that in 2013?
Make the answer very short. 0.66. What is the ratio of the Aid flow (current US$) in Small states in 2012 to that in 2013?
Offer a terse response. 0.71. What is the difference between the highest and the second highest Aid flow (current US$) of Heavily indebted poor countries?
Give a very brief answer. 1.99e+06. What is the difference between the highest and the second highest Aid flow (current US$) in Lower middle income?
Offer a terse response. 1.41e+06. What is the difference between the highest and the second highest Aid flow (current US$) in Small states?
Ensure brevity in your answer.  5.80e+05. What is the difference between the highest and the lowest Aid flow (current US$) of Heavily indebted poor countries?
Your answer should be very brief. 7.44e+06. What is the difference between the highest and the lowest Aid flow (current US$) in Lower middle income?
Keep it short and to the point. 4.95e+06. What is the difference between the highest and the lowest Aid flow (current US$) of Small states?
Keep it short and to the point. 3.46e+06. What is the difference between the highest and the lowest Aid flow (current US$) of Nicaragua?
Offer a very short reply. 2.15e+06. 